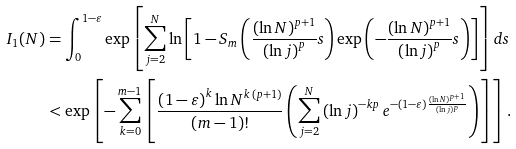<formula> <loc_0><loc_0><loc_500><loc_500>I _ { 1 } ( N ) & = \int _ { 0 } ^ { 1 - \varepsilon } \exp \left [ \sum _ { j = 2 } ^ { N } \ln \left [ 1 - S _ { m } \left ( \frac { ( \ln N ) ^ { p + 1 } } { \left ( \ln j \right ) ^ { p } } s \right ) \exp { \left ( - \frac { ( \ln N ) ^ { p + 1 } } { \left ( \ln j \right ) ^ { p } } s \right ) } \right ] \right ] d s \\ & < \exp \left [ - \sum _ { k = 0 } ^ { m - 1 } \left [ \frac { \left ( 1 - \varepsilon \right ) ^ { k } \ln N ^ { k \, ( p + 1 ) } } { \left ( m - 1 \right ) ! } \left ( \sum _ { j = 2 } ^ { N } \left ( \ln j \right ) ^ { - k p } e ^ { - \left ( 1 - \varepsilon \right ) \frac { \left ( \ln N \right ) ^ { p + 1 } } { \left ( \ln j \right ) ^ { p } } } \right ) \right ] \right ] .</formula> 